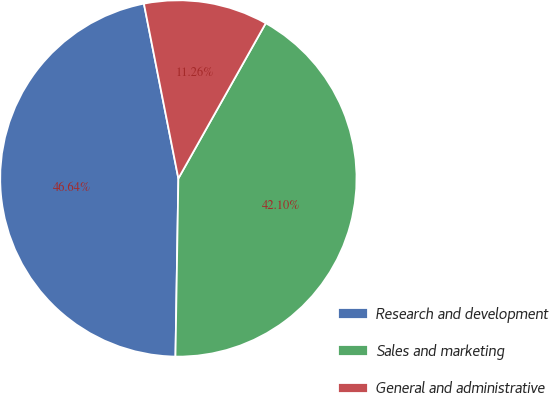<chart> <loc_0><loc_0><loc_500><loc_500><pie_chart><fcel>Research and development<fcel>Sales and marketing<fcel>General and administrative<nl><fcel>46.64%<fcel>42.1%<fcel>11.26%<nl></chart> 